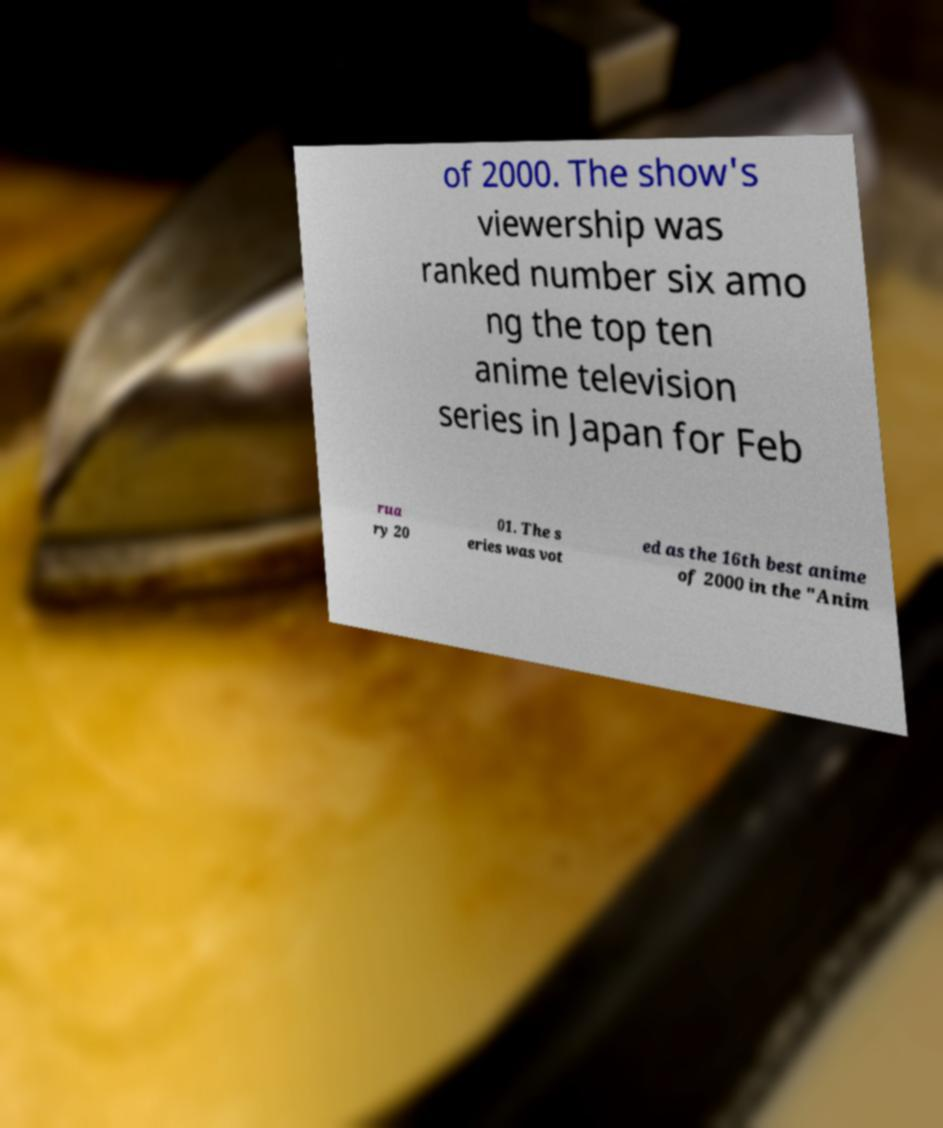What messages or text are displayed in this image? I need them in a readable, typed format. of 2000. The show's viewership was ranked number six amo ng the top ten anime television series in Japan for Feb rua ry 20 01. The s eries was vot ed as the 16th best anime of 2000 in the "Anim 